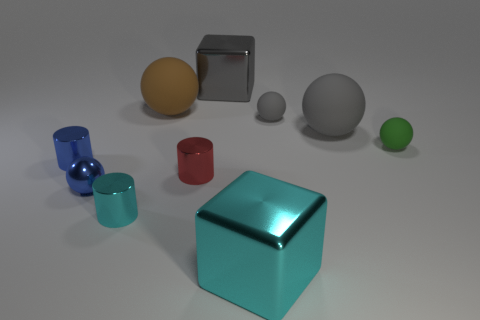Subtract all brown balls. How many balls are left? 4 Subtract all blue balls. How many balls are left? 4 Subtract all cyan balls. Subtract all brown blocks. How many balls are left? 5 Subtract all blocks. How many objects are left? 8 Add 4 metal things. How many metal things are left? 10 Add 5 tiny red shiny cylinders. How many tiny red shiny cylinders exist? 6 Subtract 0 yellow cubes. How many objects are left? 10 Subtract all tiny metallic cylinders. Subtract all large shiny objects. How many objects are left? 5 